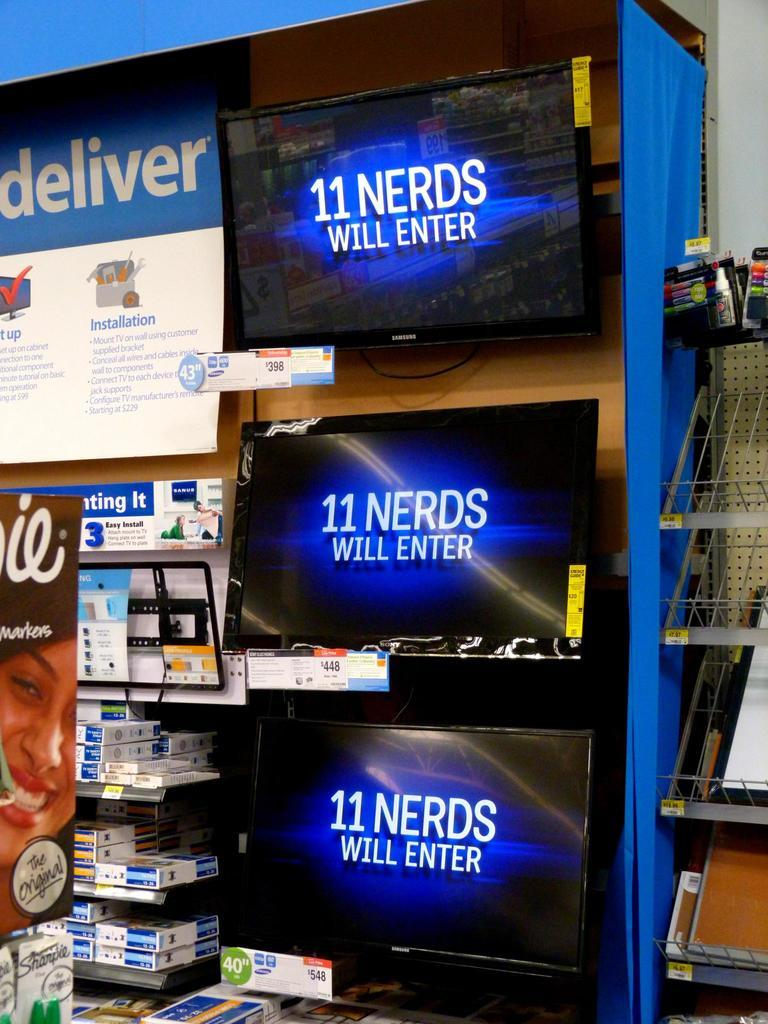<image>
Relay a brief, clear account of the picture shown. A store display shows three computer monitors at price points from $398 to $548, each displaying the phrase, "11 Nerds Will Enter." 